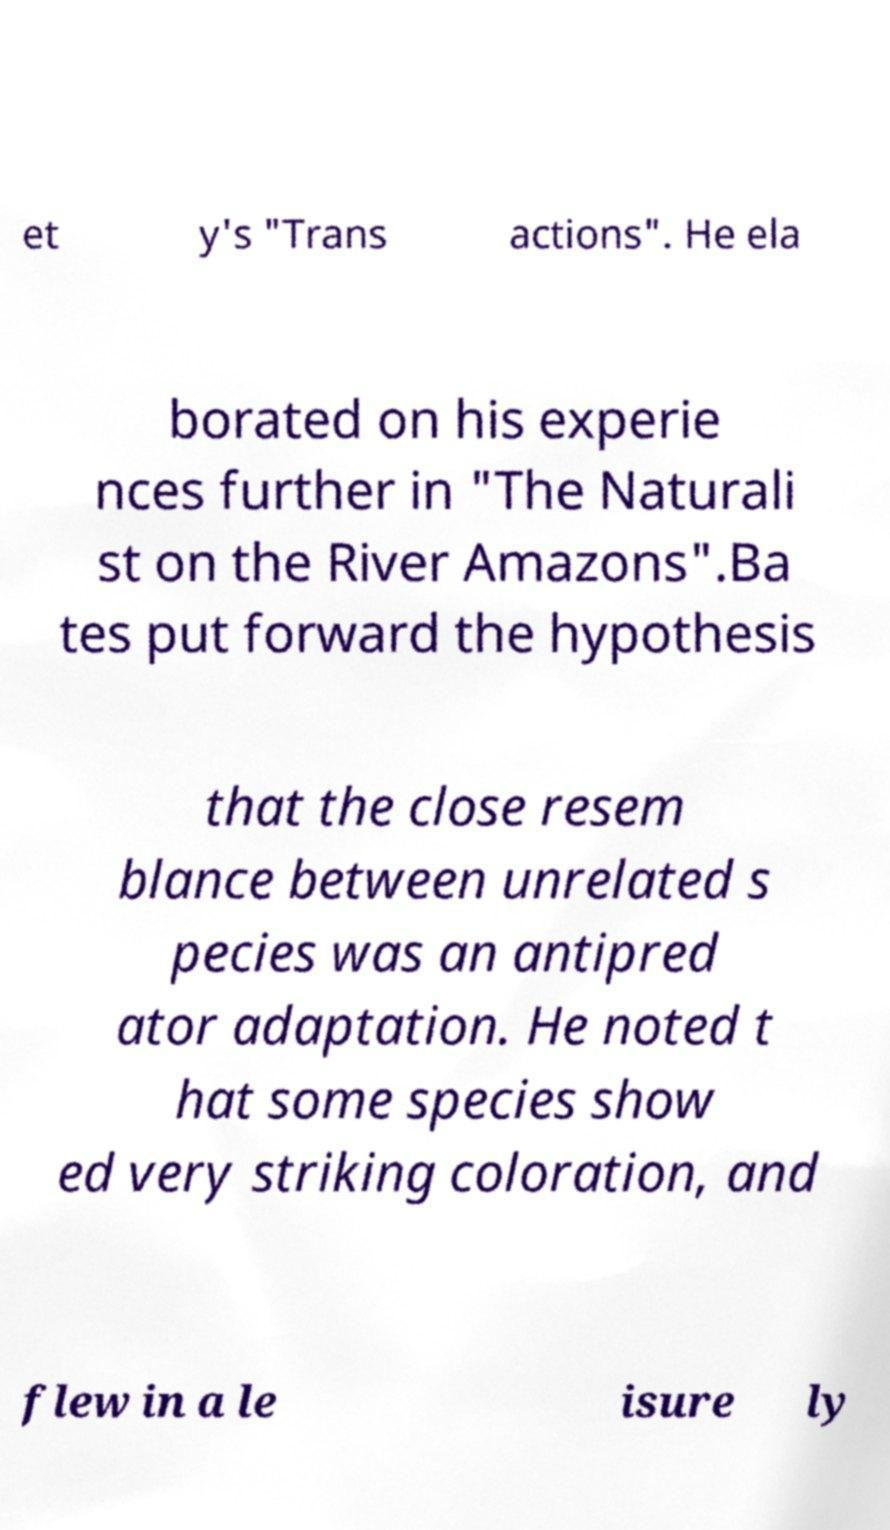Could you extract and type out the text from this image? et y's "Trans actions". He ela borated on his experie nces further in "The Naturali st on the River Amazons".Ba tes put forward the hypothesis that the close resem blance between unrelated s pecies was an antipred ator adaptation. He noted t hat some species show ed very striking coloration, and flew in a le isure ly 